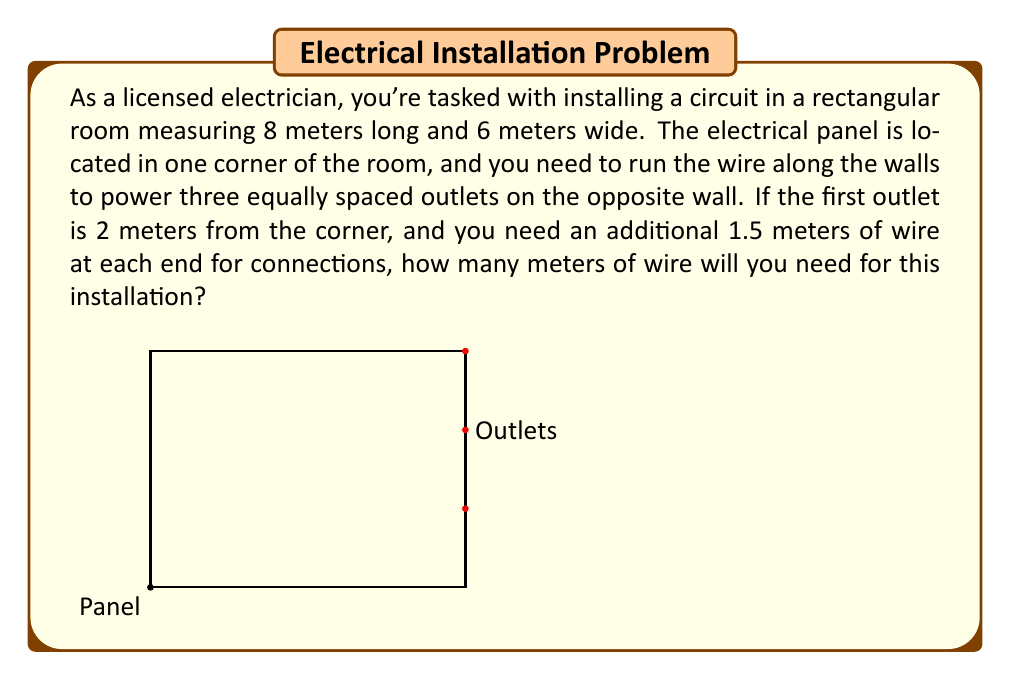Teach me how to tackle this problem. Let's break this problem down step by step:

1) First, let's calculate the distance the wire needs to travel along the walls:
   - From the panel to the first outlet: 8 m + 4 m = 12 m
   - Between the first and second outlet: 2 m
   - Between the second and third outlet: 2 m

2) Total distance along the walls:
   $$ 12 \text{ m} + 2 \text{ m} + 2 \text{ m} = 16 \text{ m} $$

3) Now, we need to account for the additional wire needed at each end:
   - At the panel end: 1.5 m
   - At the last outlet: 1.5 m

4) Total additional wire:
   $$ 1.5 \text{ m} + 1.5 \text{ m} = 3 \text{ m} $$

5) Finally, we sum up the total wire needed:
   $$ \text{Total wire} = \text{Distance along walls} + \text{Additional wire} $$
   $$ \text{Total wire} = 16 \text{ m} + 3 \text{ m} = 19 \text{ m} $$

Therefore, you will need 19 meters of wire for this circuit installation.
Answer: 19 meters 